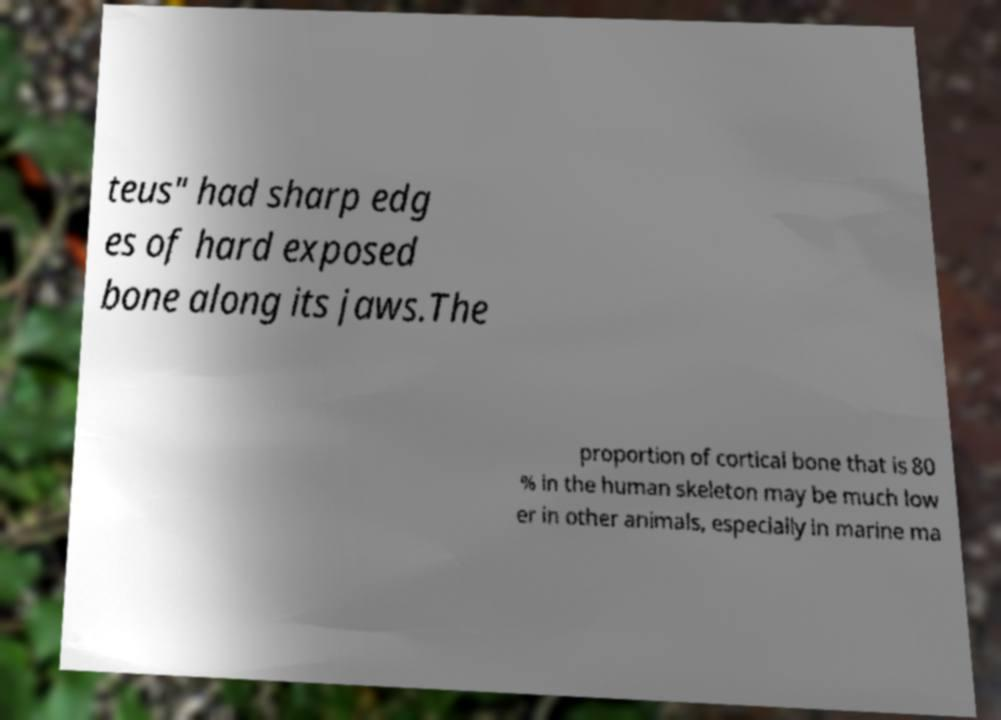There's text embedded in this image that I need extracted. Can you transcribe it verbatim? teus" had sharp edg es of hard exposed bone along its jaws.The proportion of cortical bone that is 80 % in the human skeleton may be much low er in other animals, especially in marine ma 